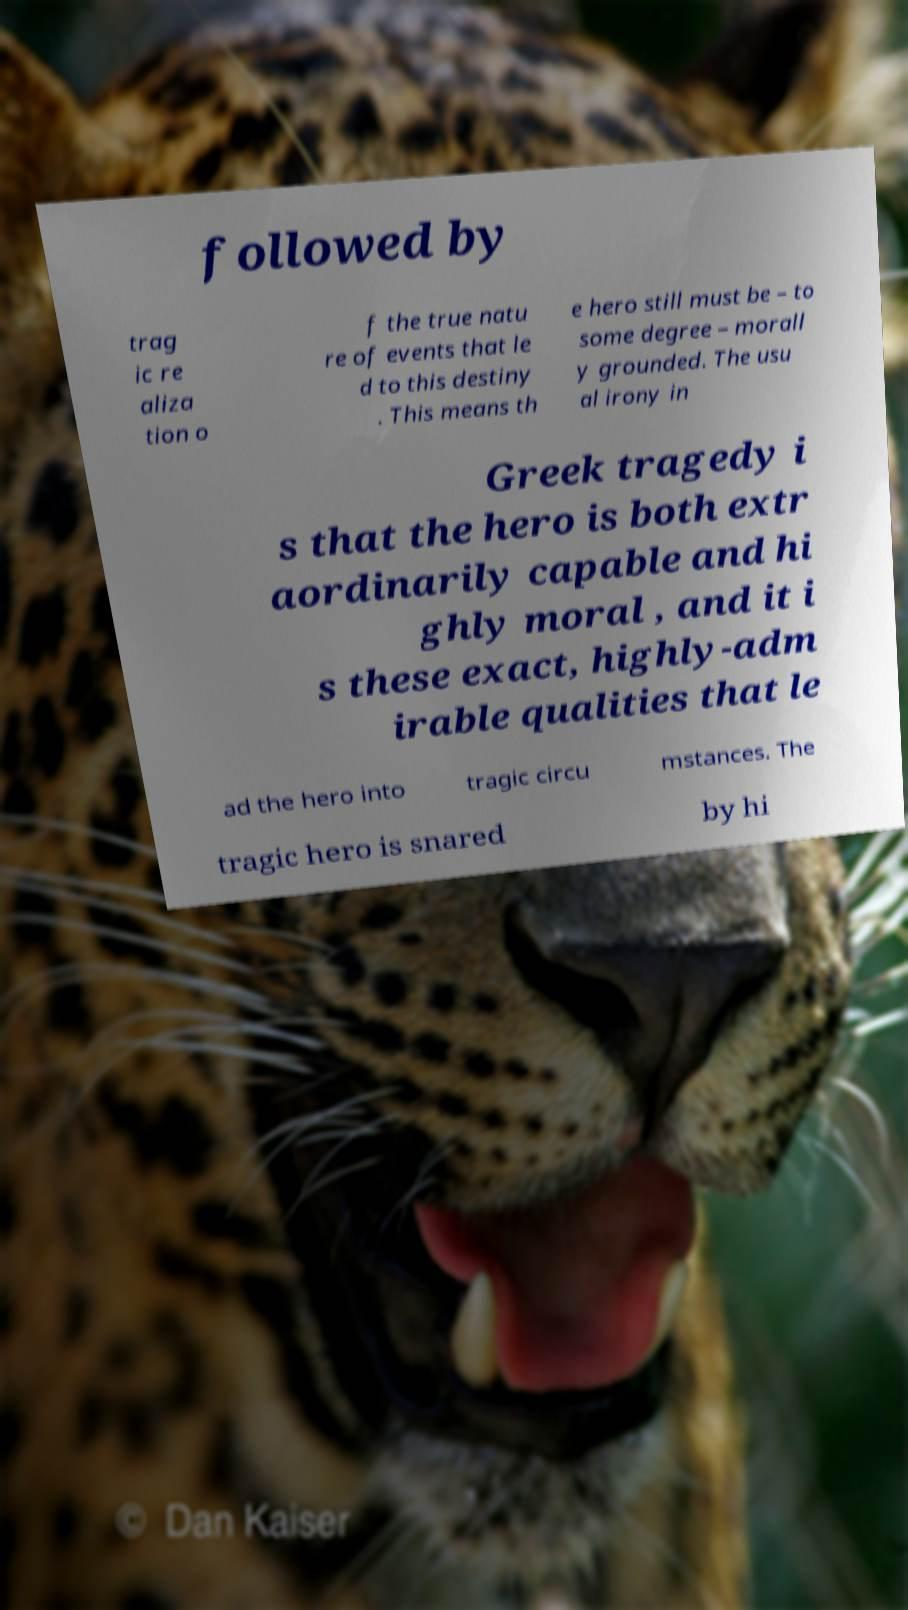Please identify and transcribe the text found in this image. followed by trag ic re aliza tion o f the true natu re of events that le d to this destiny . This means th e hero still must be – to some degree – morall y grounded. The usu al irony in Greek tragedy i s that the hero is both extr aordinarily capable and hi ghly moral , and it i s these exact, highly-adm irable qualities that le ad the hero into tragic circu mstances. The tragic hero is snared by hi 